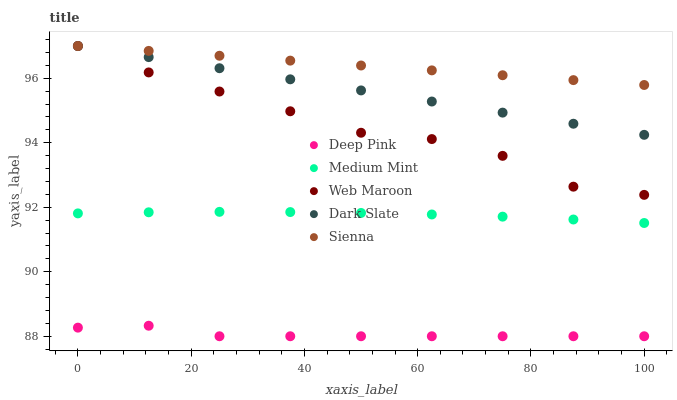Does Deep Pink have the minimum area under the curve?
Answer yes or no. Yes. Does Sienna have the maximum area under the curve?
Answer yes or no. Yes. Does Dark Slate have the minimum area under the curve?
Answer yes or no. No. Does Dark Slate have the maximum area under the curve?
Answer yes or no. No. Is Sienna the smoothest?
Answer yes or no. Yes. Is Web Maroon the roughest?
Answer yes or no. Yes. Is Dark Slate the smoothest?
Answer yes or no. No. Is Dark Slate the roughest?
Answer yes or no. No. Does Deep Pink have the lowest value?
Answer yes or no. Yes. Does Dark Slate have the lowest value?
Answer yes or no. No. Does Sienna have the highest value?
Answer yes or no. Yes. Does Deep Pink have the highest value?
Answer yes or no. No. Is Deep Pink less than Sienna?
Answer yes or no. Yes. Is Dark Slate greater than Medium Mint?
Answer yes or no. Yes. Does Web Maroon intersect Sienna?
Answer yes or no. Yes. Is Web Maroon less than Sienna?
Answer yes or no. No. Is Web Maroon greater than Sienna?
Answer yes or no. No. Does Deep Pink intersect Sienna?
Answer yes or no. No. 